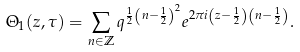<formula> <loc_0><loc_0><loc_500><loc_500>\Theta _ { 1 } ( z , \tau ) = \sum _ { n \in \mathbb { Z } } q ^ { \frac { 1 } { 2 } \left ( n - \frac { 1 } { 2 } \right ) ^ { 2 } } e ^ { 2 \pi i \left ( z - \frac { 1 } { 2 } \right ) \left ( n - \frac { 1 } { 2 } \right ) } .</formula> 